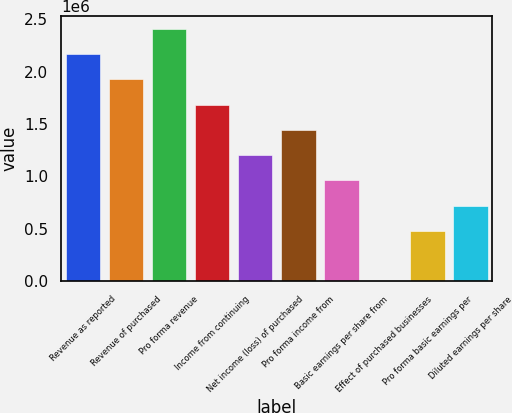<chart> <loc_0><loc_0><loc_500><loc_500><bar_chart><fcel>Revenue as reported<fcel>Revenue of purchased<fcel>Pro forma revenue<fcel>Income from continuing<fcel>Net income (loss) of purchased<fcel>Pro forma income from<fcel>Basic earnings per share from<fcel>Effect of purchased businesses<fcel>Pro forma basic earnings per<fcel>Diluted earnings per share<nl><fcel>2.1667e+06<fcel>1.92595e+06<fcel>2.40744e+06<fcel>1.68521e+06<fcel>1.20372e+06<fcel>1.44447e+06<fcel>962977<fcel>0.03<fcel>481489<fcel>722233<nl></chart> 